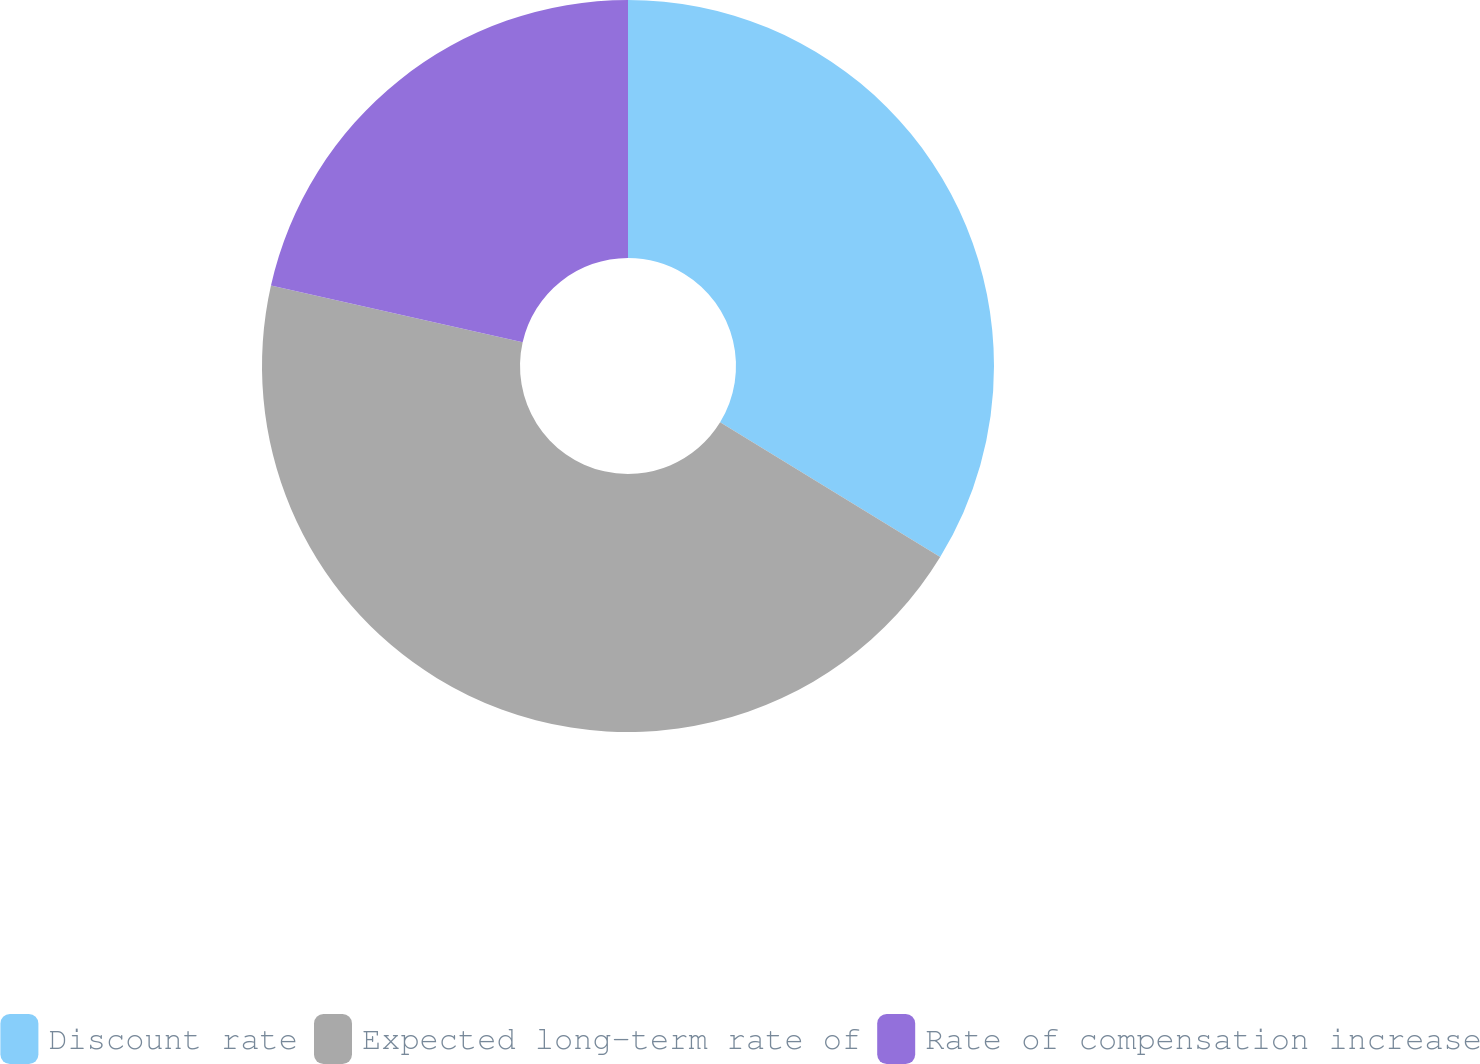<chart> <loc_0><loc_0><loc_500><loc_500><pie_chart><fcel>Discount rate<fcel>Expected long-term rate of<fcel>Rate of compensation increase<nl><fcel>33.74%<fcel>44.79%<fcel>21.47%<nl></chart> 